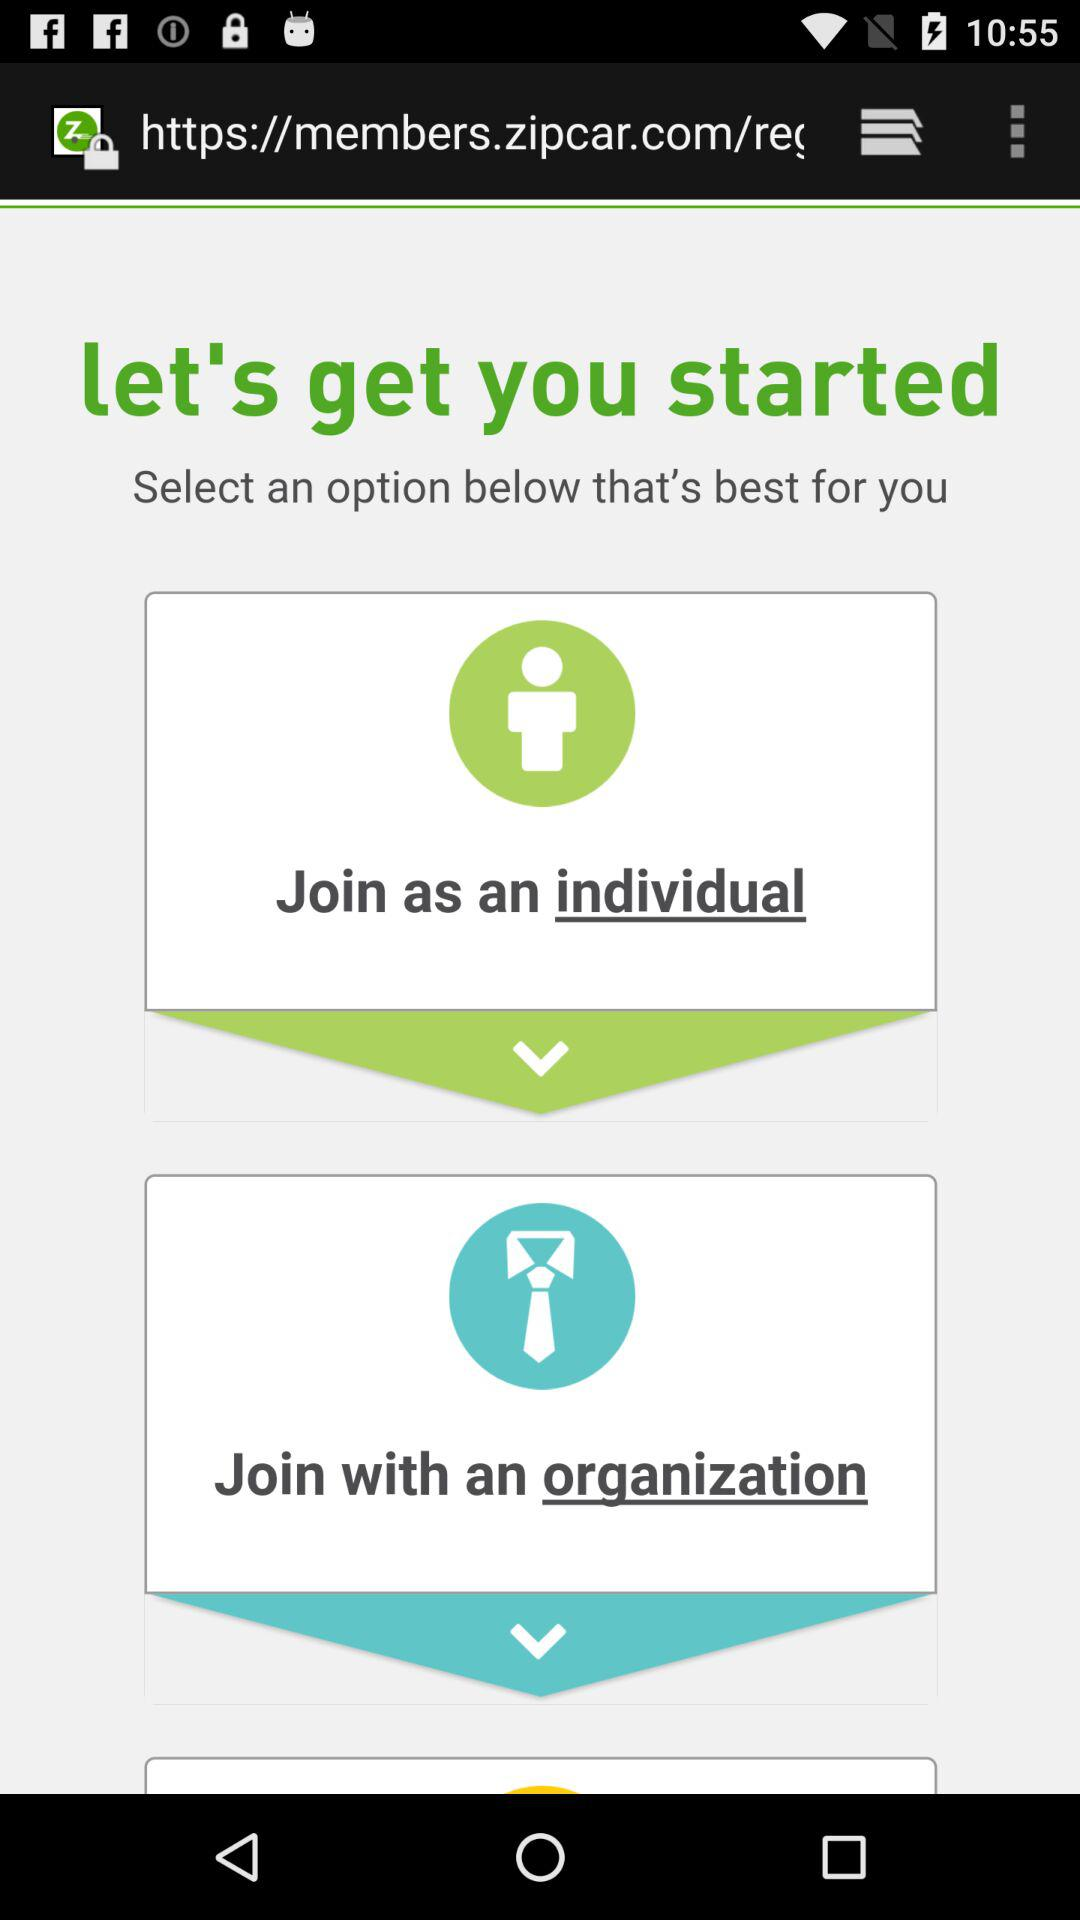How many options are there for joining Zipcar?
Answer the question using a single word or phrase. 2 